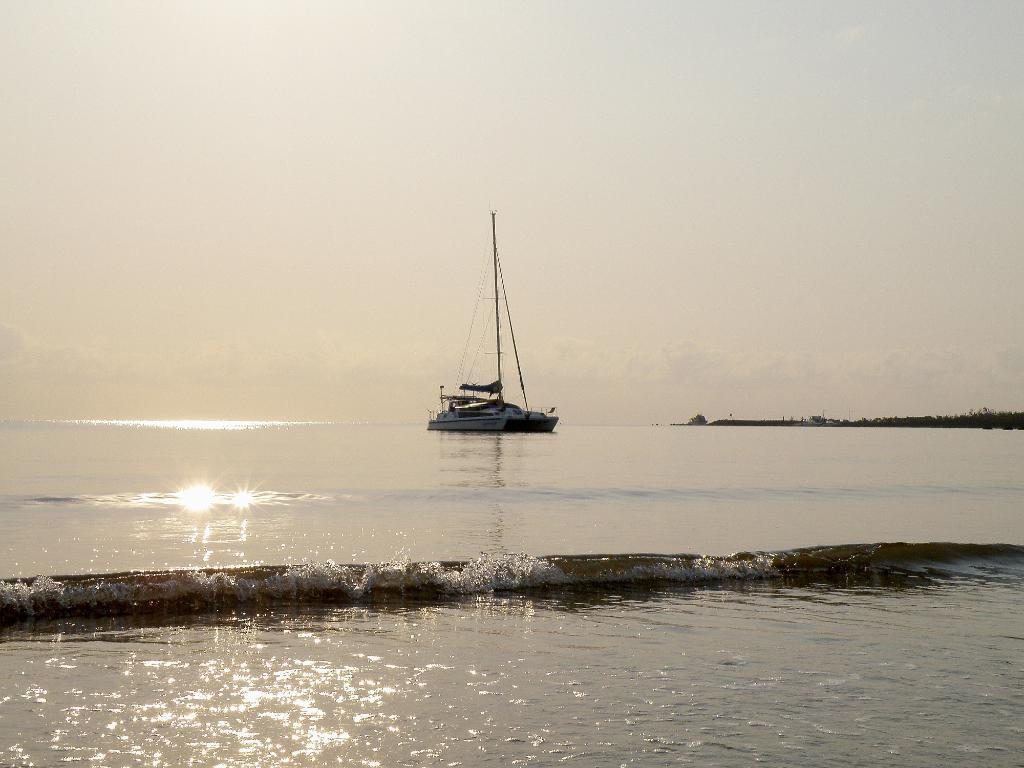What is the main subject of the image? The main subject of the image is a ship. Where is the ship located? The ship is on the water. What can be seen in the background of the image? There is sky visible in the background of the image. How many donkeys are pulling the ship in the image? There are no donkeys present in the image, and therefore no such activity can be observed. What type of trucks can be seen on the slope in the image? There are no trucks or slopes present in the image; it features a ship on the water with sky in the background. 